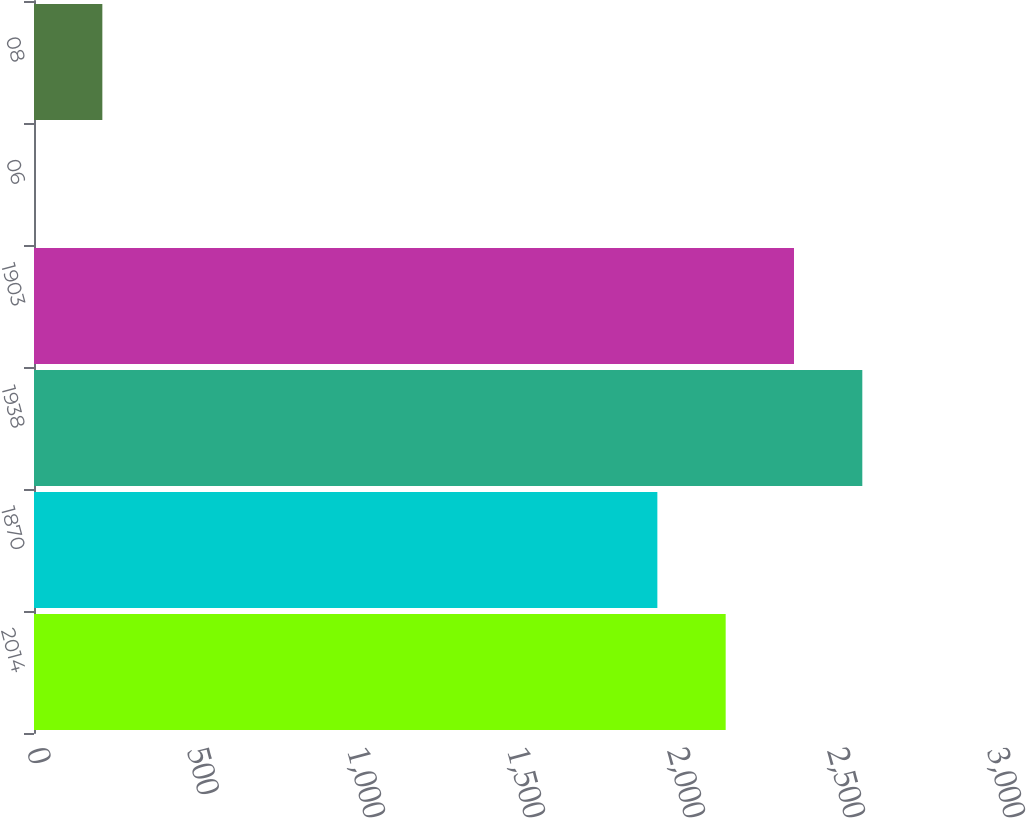<chart> <loc_0><loc_0><loc_500><loc_500><bar_chart><fcel>2014<fcel>1870<fcel>1938<fcel>1903<fcel>06<fcel>08<nl><fcel>2161.49<fcel>1948<fcel>2588.47<fcel>2374.98<fcel>0.09<fcel>213.58<nl></chart> 